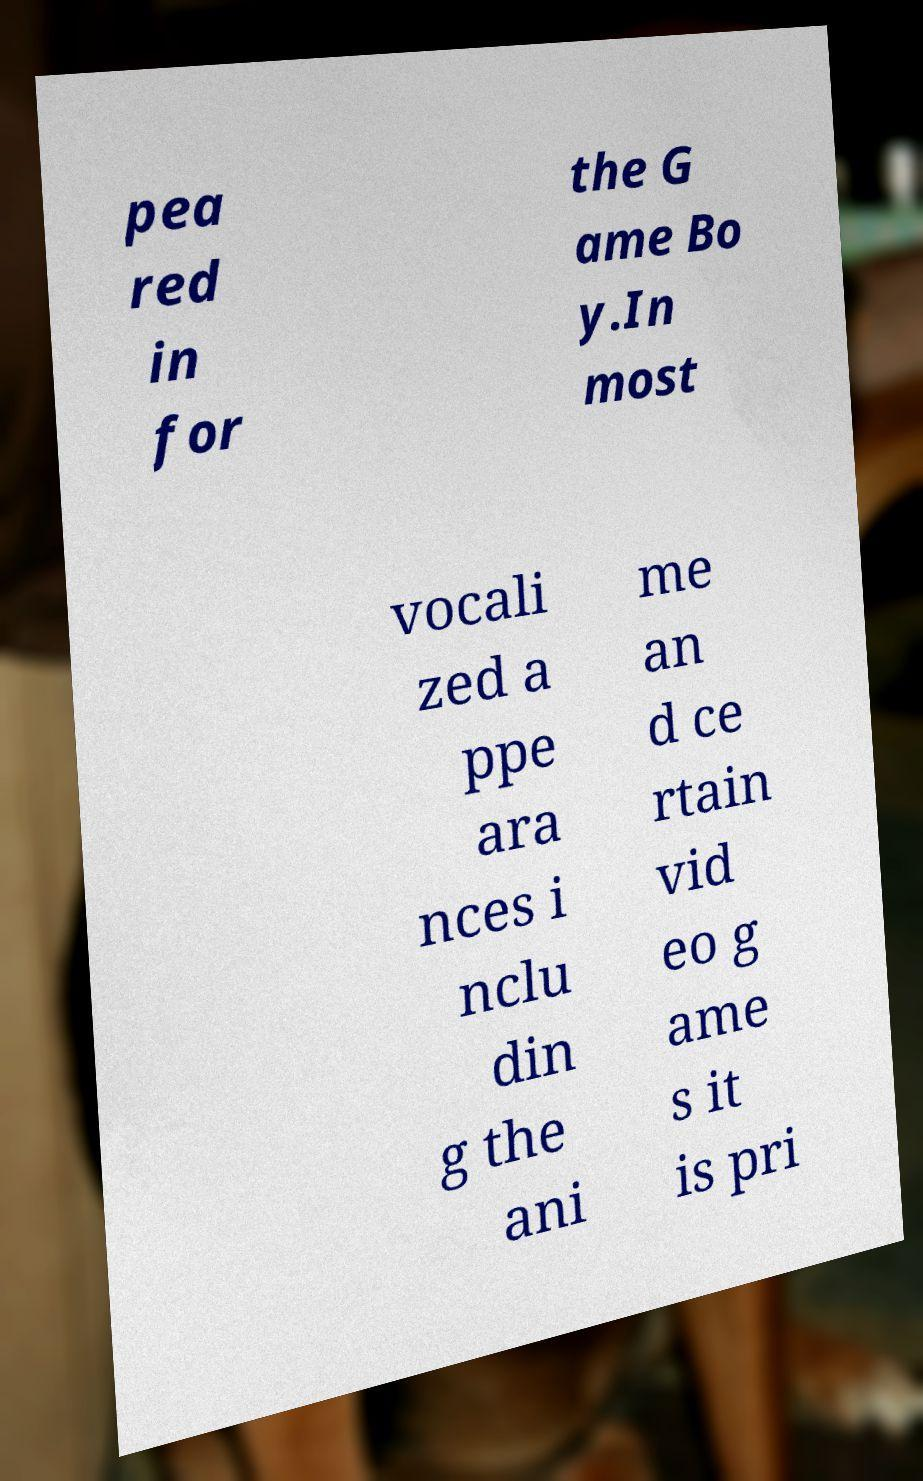There's text embedded in this image that I need extracted. Can you transcribe it verbatim? pea red in for the G ame Bo y.In most vocali zed a ppe ara nces i nclu din g the ani me an d ce rtain vid eo g ame s it is pri 